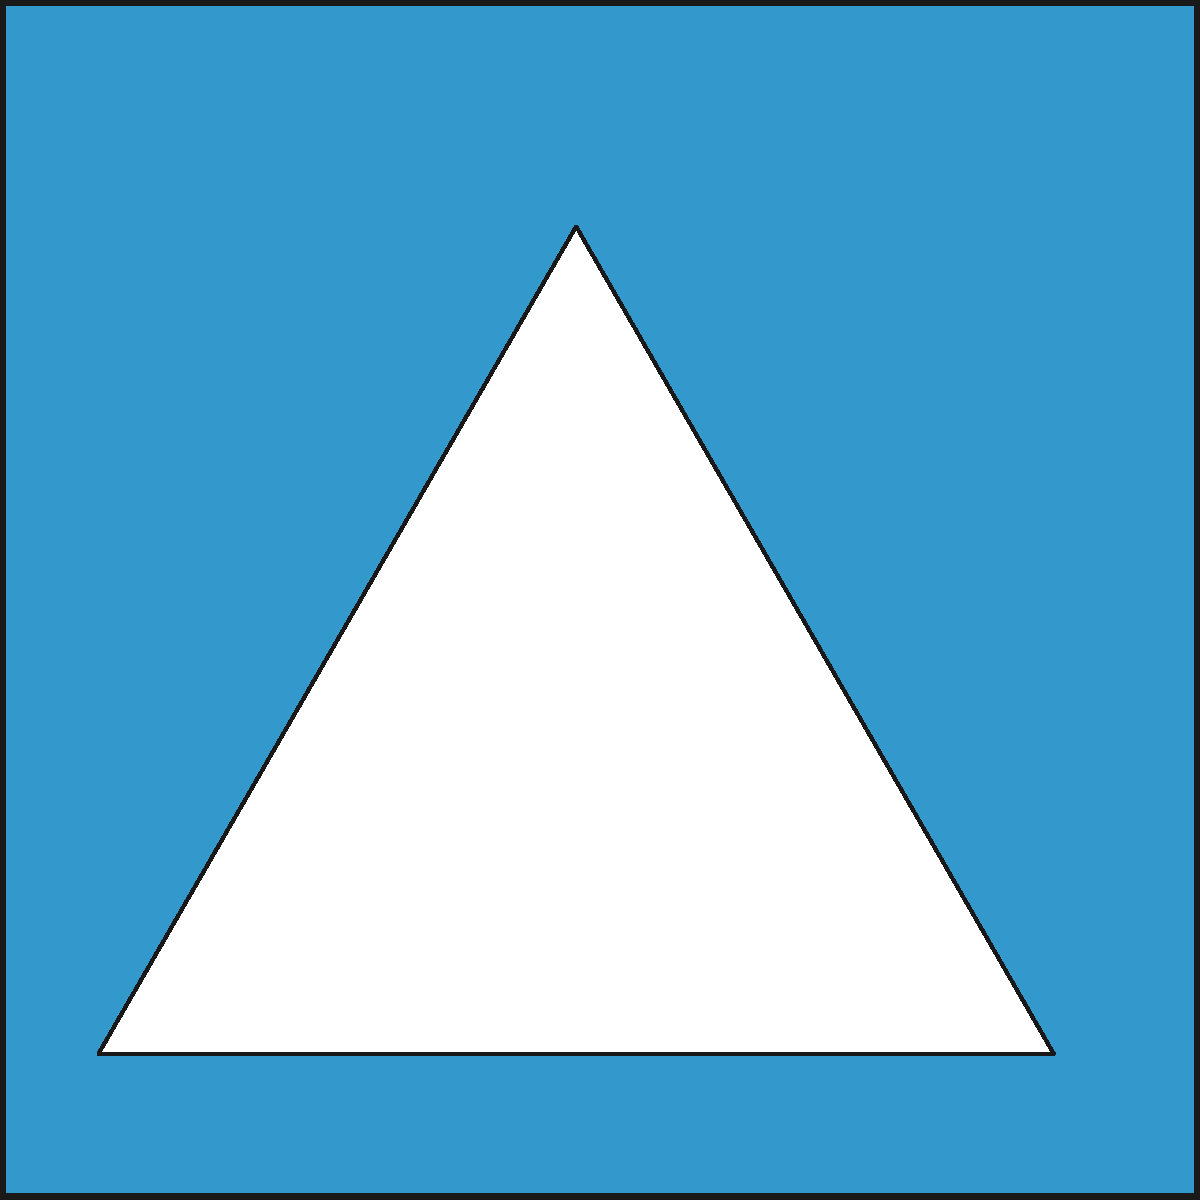As a regular user of our company's product, you've noticed that the logo has undergone a redesign. The new logo consists of a blue square with a white triangle inside and the letter "P" at the center. How many rotational symmetries does this logo have? To determine the number of rotational symmetries, we need to analyze the logo's components and their arrangement:

1. The blue square background has 4-fold rotational symmetry (90°, 180°, 270°, and 360°).
2. The white triangle has 3-fold rotational symmetry (120°, 240°, and 360°).
3. The letter "P" has only 1-fold rotational symmetry (360°).

To find the overall rotational symmetry of the logo, we need to consider the least common multiple of these individual symmetries:

$$\text{LCM}(4, 3, 1) = 1$$

This means that the logo as a whole has only one rotational symmetry, which is the 360° rotation (or no rotation at all).

The reason for this is that the asymmetric placement of the triangle within the square and the orientation of the letter "P" break the higher-order symmetries of the individual components.
Answer: 1 rotational symmetry 